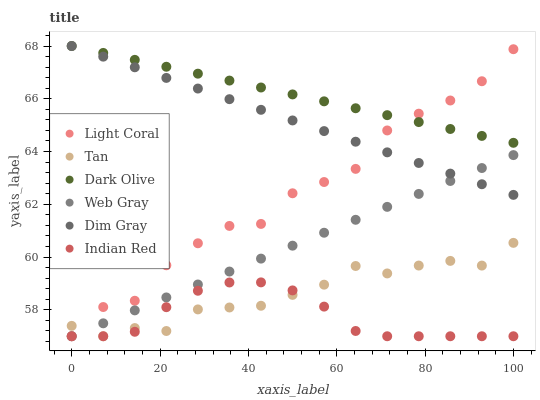Does Indian Red have the minimum area under the curve?
Answer yes or no. Yes. Does Dark Olive have the maximum area under the curve?
Answer yes or no. Yes. Does Light Coral have the minimum area under the curve?
Answer yes or no. No. Does Light Coral have the maximum area under the curve?
Answer yes or no. No. Is Web Gray the smoothest?
Answer yes or no. Yes. Is Light Coral the roughest?
Answer yes or no. Yes. Is Dark Olive the smoothest?
Answer yes or no. No. Is Dark Olive the roughest?
Answer yes or no. No. Does Web Gray have the lowest value?
Answer yes or no. Yes. Does Dark Olive have the lowest value?
Answer yes or no. No. Does Dim Gray have the highest value?
Answer yes or no. Yes. Does Light Coral have the highest value?
Answer yes or no. No. Is Tan less than Dim Gray?
Answer yes or no. Yes. Is Dark Olive greater than Web Gray?
Answer yes or no. Yes. Does Web Gray intersect Tan?
Answer yes or no. Yes. Is Web Gray less than Tan?
Answer yes or no. No. Is Web Gray greater than Tan?
Answer yes or no. No. Does Tan intersect Dim Gray?
Answer yes or no. No. 